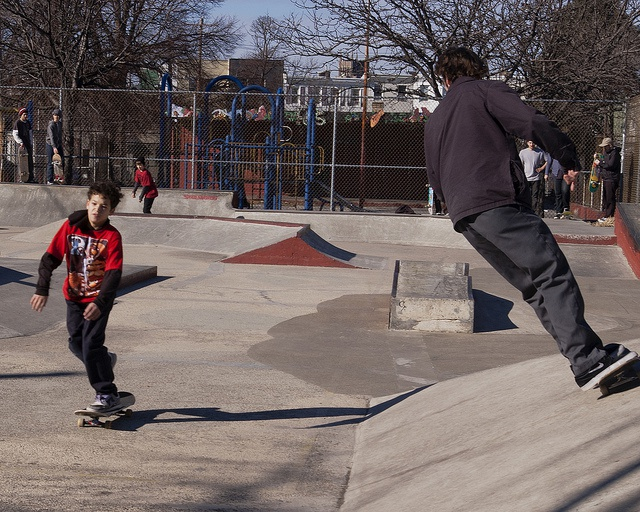Describe the objects in this image and their specific colors. I can see people in black and gray tones, people in black, maroon, gray, and brown tones, skateboard in black, darkgray, lightgray, and gray tones, people in black, gray, and darkgray tones, and people in black, gray, and maroon tones in this image. 